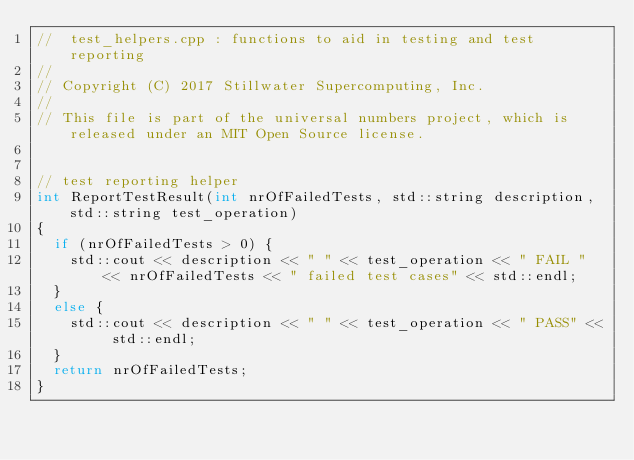Convert code to text. <code><loc_0><loc_0><loc_500><loc_500><_C++_>//  test_helpers.cpp : functions to aid in testing and test reporting
//
// Copyright (C) 2017 Stillwater Supercomputing, Inc.
//
// This file is part of the universal numbers project, which is released under an MIT Open Source license.


// test reporting helper
int ReportTestResult(int nrOfFailedTests, std::string description, std::string test_operation)
{
	if (nrOfFailedTests > 0) {
		std::cout << description << " " << test_operation << " FAIL " << nrOfFailedTests << " failed test cases" << std::endl;
	}
	else {
		std::cout << description << " " << test_operation << " PASS" << std::endl;
	}
	return nrOfFailedTests;
}</code> 